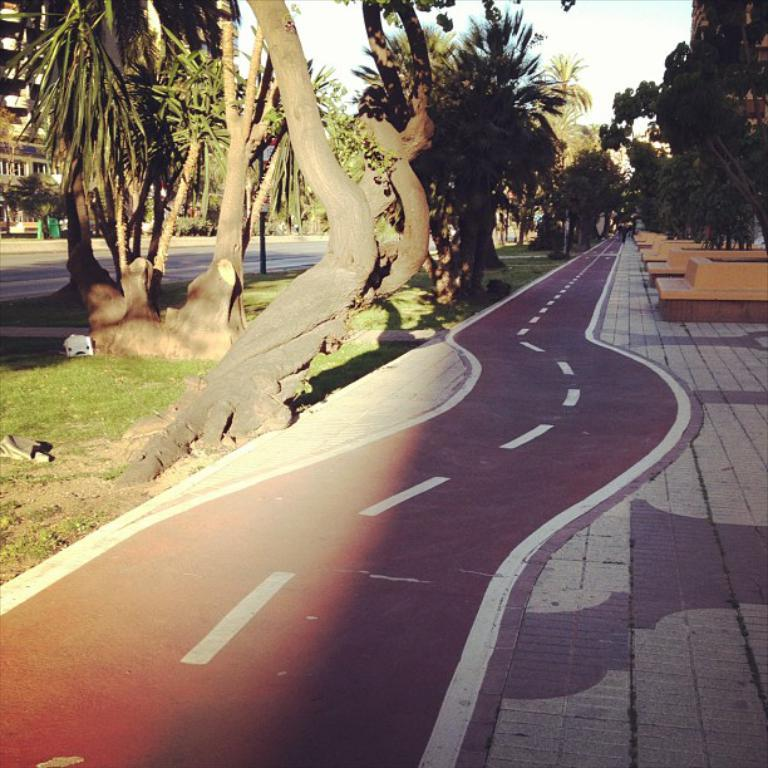What is the main subject of the image? The image depicts a road. What can be seen alongside the road? There are trees visible in the image. What type of vegetation is present near the road? Grass is present in the image. What structures are visible in the image? There are buildings in the image. What is visible in the background of the image? The sky is visible in the background of the image. How many sisters are walking on the grass in the image? There are no sisters present in the image; it depicts a road, trees, grass, buildings, and the sky. What type of powder is being used to maintain the trees in the image? There is no mention of powder or any tree maintenance activity in the image. 